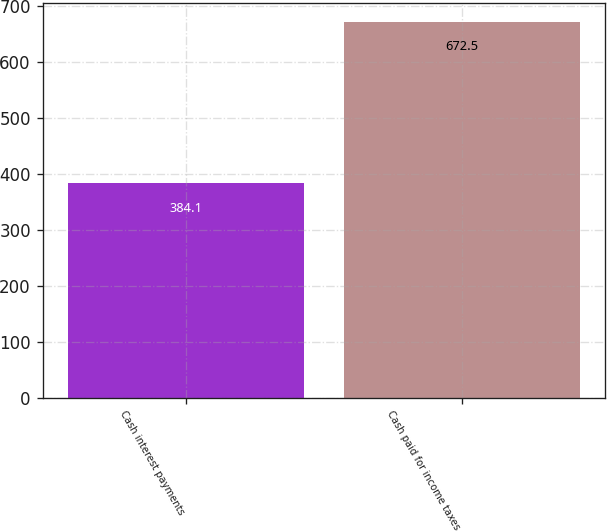Convert chart to OTSL. <chart><loc_0><loc_0><loc_500><loc_500><bar_chart><fcel>Cash interest payments<fcel>Cash paid for income taxes<nl><fcel>384.1<fcel>672.5<nl></chart> 